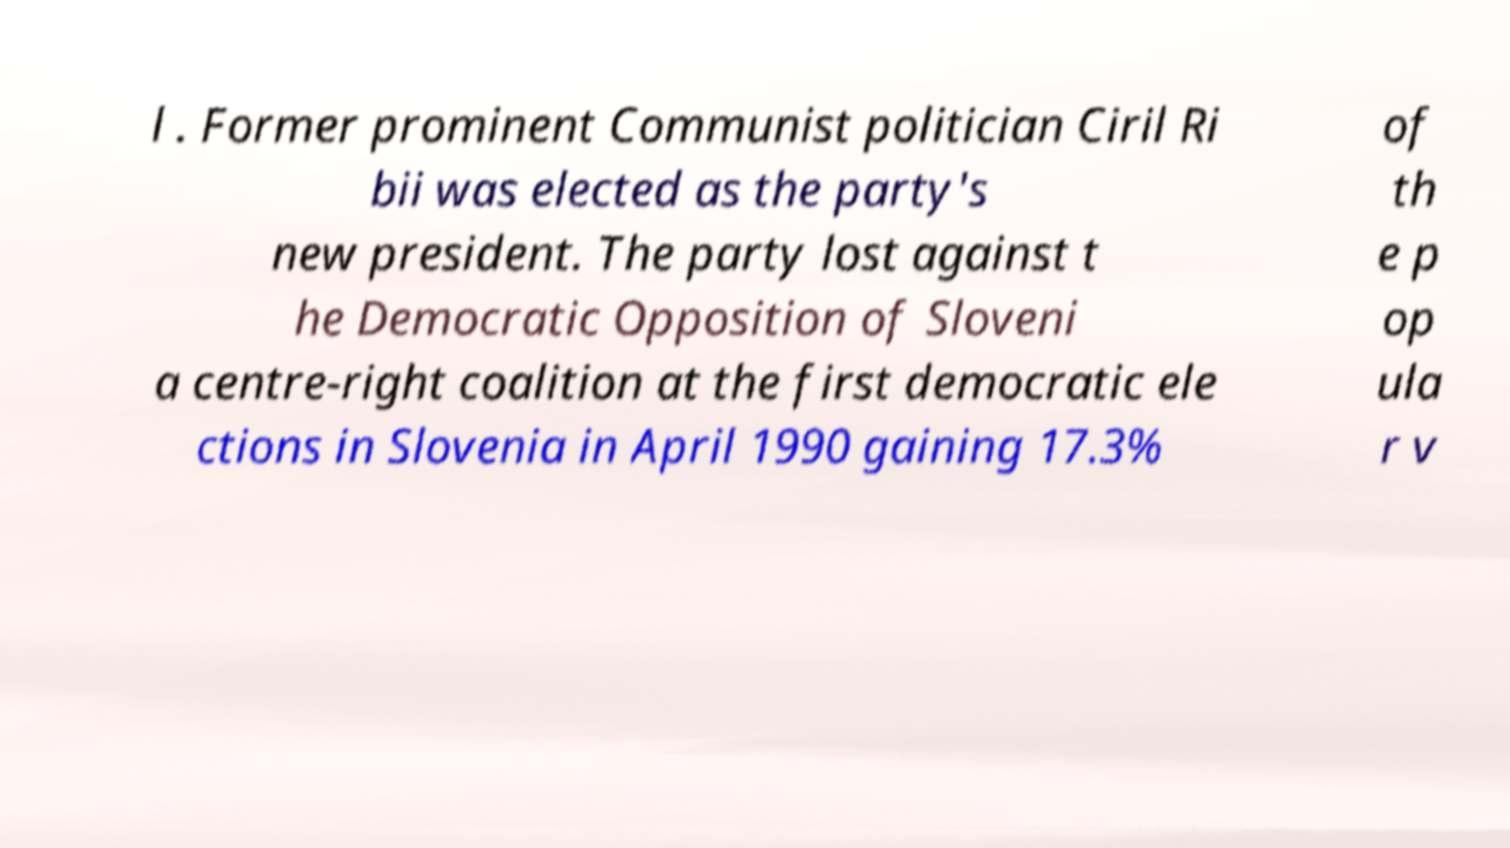Please identify and transcribe the text found in this image. l . Former prominent Communist politician Ciril Ri bii was elected as the party's new president. The party lost against t he Democratic Opposition of Sloveni a centre-right coalition at the first democratic ele ctions in Slovenia in April 1990 gaining 17.3% of th e p op ula r v 